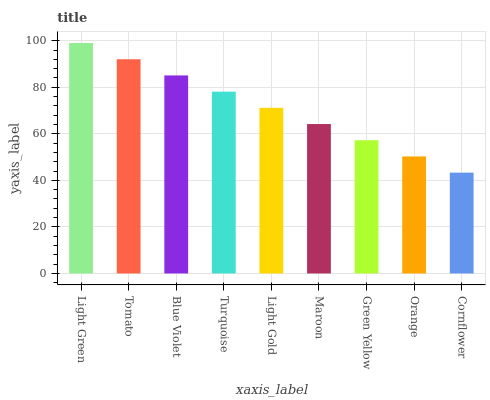Is Tomato the minimum?
Answer yes or no. No. Is Tomato the maximum?
Answer yes or no. No. Is Light Green greater than Tomato?
Answer yes or no. Yes. Is Tomato less than Light Green?
Answer yes or no. Yes. Is Tomato greater than Light Green?
Answer yes or no. No. Is Light Green less than Tomato?
Answer yes or no. No. Is Light Gold the high median?
Answer yes or no. Yes. Is Light Gold the low median?
Answer yes or no. Yes. Is Turquoise the high median?
Answer yes or no. No. Is Tomato the low median?
Answer yes or no. No. 